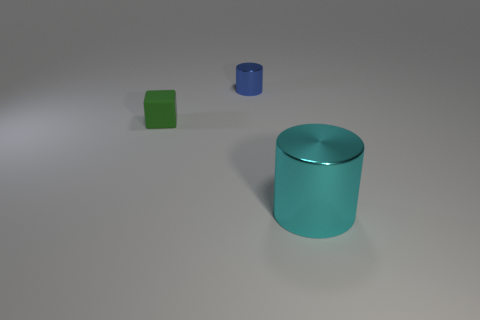Do the cyan shiny object and the metal object behind the rubber cube have the same size?
Your answer should be compact. No. What number of large cylinders are left of the metallic cylinder that is in front of the thing that is on the left side of the blue shiny object?
Offer a terse response. 0. There is a big cyan object; how many small metallic things are behind it?
Offer a terse response. 1. The metal thing that is in front of the object that is behind the small rubber object is what color?
Provide a short and direct response. Cyan. What number of other things are the same material as the block?
Offer a terse response. 0. Are there the same number of big things left of the cyan cylinder and big brown metallic blocks?
Provide a succinct answer. Yes. What is the material of the tiny object that is on the left side of the metallic cylinder that is behind the cylinder that is to the right of the tiny metallic object?
Offer a terse response. Rubber. What color is the shiny cylinder behind the cyan metallic object?
Ensure brevity in your answer.  Blue. Is there anything else that is the same shape as the large thing?
Make the answer very short. Yes. There is a shiny cylinder that is in front of the small green block to the left of the big cyan cylinder; how big is it?
Your response must be concise. Large. 